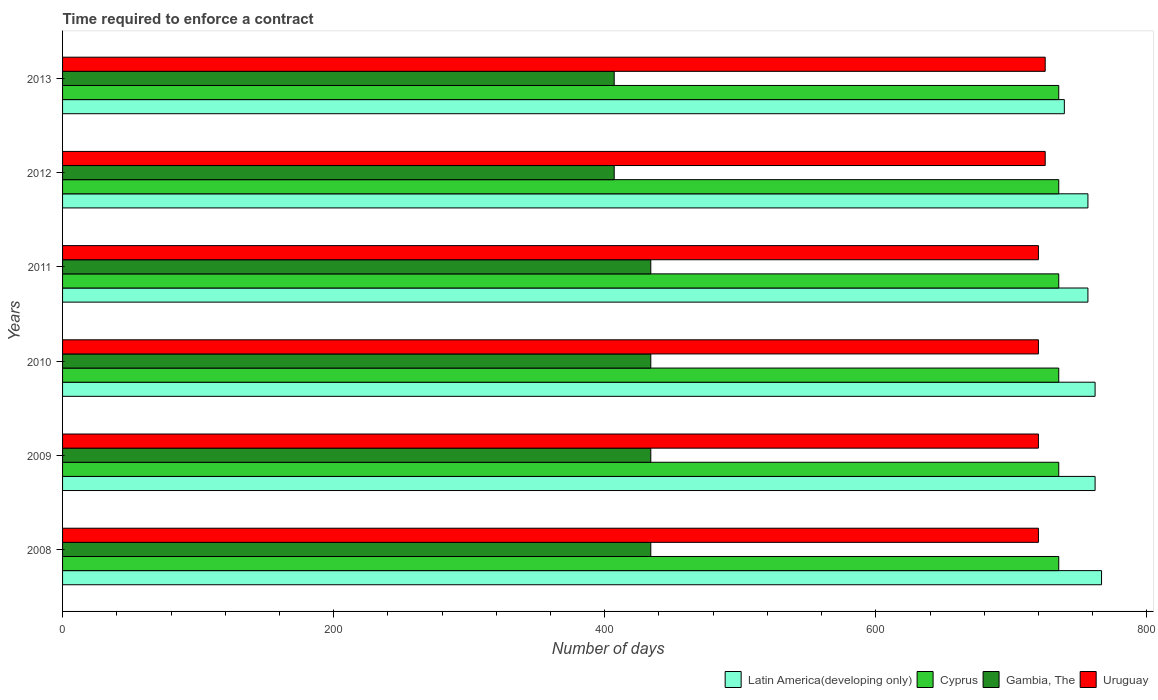Are the number of bars per tick equal to the number of legend labels?
Make the answer very short. Yes. Are the number of bars on each tick of the Y-axis equal?
Your answer should be compact. Yes. How many bars are there on the 6th tick from the top?
Offer a terse response. 4. How many bars are there on the 6th tick from the bottom?
Give a very brief answer. 4. What is the number of days required to enforce a contract in Gambia, The in 2011?
Your response must be concise. 434. Across all years, what is the maximum number of days required to enforce a contract in Latin America(developing only)?
Offer a very short reply. 766.57. Across all years, what is the minimum number of days required to enforce a contract in Uruguay?
Ensure brevity in your answer.  720. What is the total number of days required to enforce a contract in Latin America(developing only) in the graph?
Offer a terse response. 4542.37. What is the difference between the number of days required to enforce a contract in Gambia, The in 2010 and the number of days required to enforce a contract in Latin America(developing only) in 2009?
Make the answer very short. -327.81. What is the average number of days required to enforce a contract in Gambia, The per year?
Your response must be concise. 425. In the year 2011, what is the difference between the number of days required to enforce a contract in Latin America(developing only) and number of days required to enforce a contract in Uruguay?
Provide a short and direct response. 36.52. What is the ratio of the number of days required to enforce a contract in Latin America(developing only) in 2012 to that in 2013?
Make the answer very short. 1.02. What is the difference between the highest and the lowest number of days required to enforce a contract in Latin America(developing only)?
Your answer should be compact. 27.44. What does the 1st bar from the top in 2011 represents?
Offer a very short reply. Uruguay. What does the 3rd bar from the bottom in 2010 represents?
Your response must be concise. Gambia, The. Is it the case that in every year, the sum of the number of days required to enforce a contract in Uruguay and number of days required to enforce a contract in Gambia, The is greater than the number of days required to enforce a contract in Latin America(developing only)?
Ensure brevity in your answer.  Yes. How many bars are there?
Offer a terse response. 24. How many years are there in the graph?
Give a very brief answer. 6. Are the values on the major ticks of X-axis written in scientific E-notation?
Offer a terse response. No. Where does the legend appear in the graph?
Provide a short and direct response. Bottom right. How are the legend labels stacked?
Offer a terse response. Horizontal. What is the title of the graph?
Your answer should be compact. Time required to enforce a contract. Does "Greece" appear as one of the legend labels in the graph?
Your answer should be compact. No. What is the label or title of the X-axis?
Your response must be concise. Number of days. What is the label or title of the Y-axis?
Give a very brief answer. Years. What is the Number of days of Latin America(developing only) in 2008?
Your answer should be compact. 766.57. What is the Number of days of Cyprus in 2008?
Ensure brevity in your answer.  735. What is the Number of days in Gambia, The in 2008?
Offer a terse response. 434. What is the Number of days of Uruguay in 2008?
Make the answer very short. 720. What is the Number of days in Latin America(developing only) in 2009?
Make the answer very short. 761.81. What is the Number of days of Cyprus in 2009?
Provide a short and direct response. 735. What is the Number of days of Gambia, The in 2009?
Offer a terse response. 434. What is the Number of days of Uruguay in 2009?
Keep it short and to the point. 720. What is the Number of days in Latin America(developing only) in 2010?
Offer a terse response. 761.81. What is the Number of days in Cyprus in 2010?
Provide a succinct answer. 735. What is the Number of days in Gambia, The in 2010?
Offer a terse response. 434. What is the Number of days of Uruguay in 2010?
Your answer should be compact. 720. What is the Number of days of Latin America(developing only) in 2011?
Your answer should be compact. 756.52. What is the Number of days of Cyprus in 2011?
Provide a succinct answer. 735. What is the Number of days of Gambia, The in 2011?
Your answer should be very brief. 434. What is the Number of days in Uruguay in 2011?
Make the answer very short. 720. What is the Number of days of Latin America(developing only) in 2012?
Offer a terse response. 756.52. What is the Number of days of Cyprus in 2012?
Provide a succinct answer. 735. What is the Number of days of Gambia, The in 2012?
Your response must be concise. 407. What is the Number of days in Uruguay in 2012?
Ensure brevity in your answer.  725. What is the Number of days of Latin America(developing only) in 2013?
Keep it short and to the point. 739.13. What is the Number of days in Cyprus in 2013?
Your response must be concise. 735. What is the Number of days in Gambia, The in 2013?
Give a very brief answer. 407. What is the Number of days in Uruguay in 2013?
Provide a short and direct response. 725. Across all years, what is the maximum Number of days in Latin America(developing only)?
Give a very brief answer. 766.57. Across all years, what is the maximum Number of days in Cyprus?
Provide a succinct answer. 735. Across all years, what is the maximum Number of days in Gambia, The?
Your response must be concise. 434. Across all years, what is the maximum Number of days of Uruguay?
Provide a short and direct response. 725. Across all years, what is the minimum Number of days of Latin America(developing only)?
Your answer should be very brief. 739.13. Across all years, what is the minimum Number of days of Cyprus?
Your answer should be very brief. 735. Across all years, what is the minimum Number of days of Gambia, The?
Offer a very short reply. 407. Across all years, what is the minimum Number of days of Uruguay?
Provide a succinct answer. 720. What is the total Number of days in Latin America(developing only) in the graph?
Provide a succinct answer. 4542.37. What is the total Number of days of Cyprus in the graph?
Keep it short and to the point. 4410. What is the total Number of days in Gambia, The in the graph?
Your response must be concise. 2550. What is the total Number of days of Uruguay in the graph?
Your answer should be very brief. 4330. What is the difference between the Number of days in Latin America(developing only) in 2008 and that in 2009?
Ensure brevity in your answer.  4.76. What is the difference between the Number of days of Uruguay in 2008 and that in 2009?
Your answer should be very brief. 0. What is the difference between the Number of days in Latin America(developing only) in 2008 and that in 2010?
Keep it short and to the point. 4.76. What is the difference between the Number of days in Gambia, The in 2008 and that in 2010?
Your response must be concise. 0. What is the difference between the Number of days of Uruguay in 2008 and that in 2010?
Offer a terse response. 0. What is the difference between the Number of days of Latin America(developing only) in 2008 and that in 2011?
Offer a very short reply. 10.05. What is the difference between the Number of days in Gambia, The in 2008 and that in 2011?
Give a very brief answer. 0. What is the difference between the Number of days of Uruguay in 2008 and that in 2011?
Your answer should be compact. 0. What is the difference between the Number of days in Latin America(developing only) in 2008 and that in 2012?
Ensure brevity in your answer.  10.05. What is the difference between the Number of days of Uruguay in 2008 and that in 2012?
Keep it short and to the point. -5. What is the difference between the Number of days in Latin America(developing only) in 2008 and that in 2013?
Ensure brevity in your answer.  27.44. What is the difference between the Number of days of Uruguay in 2008 and that in 2013?
Your answer should be compact. -5. What is the difference between the Number of days in Latin America(developing only) in 2009 and that in 2010?
Your answer should be very brief. 0. What is the difference between the Number of days in Cyprus in 2009 and that in 2010?
Your response must be concise. 0. What is the difference between the Number of days in Gambia, The in 2009 and that in 2010?
Ensure brevity in your answer.  0. What is the difference between the Number of days in Latin America(developing only) in 2009 and that in 2011?
Your answer should be very brief. 5.29. What is the difference between the Number of days in Cyprus in 2009 and that in 2011?
Your answer should be very brief. 0. What is the difference between the Number of days in Gambia, The in 2009 and that in 2011?
Give a very brief answer. 0. What is the difference between the Number of days in Latin America(developing only) in 2009 and that in 2012?
Keep it short and to the point. 5.29. What is the difference between the Number of days of Latin America(developing only) in 2009 and that in 2013?
Give a very brief answer. 22.68. What is the difference between the Number of days of Cyprus in 2009 and that in 2013?
Keep it short and to the point. 0. What is the difference between the Number of days in Latin America(developing only) in 2010 and that in 2011?
Your answer should be compact. 5.29. What is the difference between the Number of days in Cyprus in 2010 and that in 2011?
Keep it short and to the point. 0. What is the difference between the Number of days in Gambia, The in 2010 and that in 2011?
Your response must be concise. 0. What is the difference between the Number of days of Uruguay in 2010 and that in 2011?
Make the answer very short. 0. What is the difference between the Number of days of Latin America(developing only) in 2010 and that in 2012?
Your response must be concise. 5.29. What is the difference between the Number of days of Latin America(developing only) in 2010 and that in 2013?
Give a very brief answer. 22.68. What is the difference between the Number of days in Cyprus in 2010 and that in 2013?
Make the answer very short. 0. What is the difference between the Number of days of Gambia, The in 2010 and that in 2013?
Your answer should be compact. 27. What is the difference between the Number of days of Cyprus in 2011 and that in 2012?
Ensure brevity in your answer.  0. What is the difference between the Number of days in Uruguay in 2011 and that in 2012?
Your response must be concise. -5. What is the difference between the Number of days of Latin America(developing only) in 2011 and that in 2013?
Your answer should be compact. 17.39. What is the difference between the Number of days of Gambia, The in 2011 and that in 2013?
Offer a very short reply. 27. What is the difference between the Number of days in Uruguay in 2011 and that in 2013?
Your answer should be very brief. -5. What is the difference between the Number of days of Latin America(developing only) in 2012 and that in 2013?
Offer a very short reply. 17.39. What is the difference between the Number of days of Cyprus in 2012 and that in 2013?
Provide a succinct answer. 0. What is the difference between the Number of days in Uruguay in 2012 and that in 2013?
Offer a terse response. 0. What is the difference between the Number of days of Latin America(developing only) in 2008 and the Number of days of Cyprus in 2009?
Offer a very short reply. 31.57. What is the difference between the Number of days of Latin America(developing only) in 2008 and the Number of days of Gambia, The in 2009?
Offer a very short reply. 332.57. What is the difference between the Number of days in Latin America(developing only) in 2008 and the Number of days in Uruguay in 2009?
Offer a very short reply. 46.57. What is the difference between the Number of days in Cyprus in 2008 and the Number of days in Gambia, The in 2009?
Ensure brevity in your answer.  301. What is the difference between the Number of days in Cyprus in 2008 and the Number of days in Uruguay in 2009?
Offer a very short reply. 15. What is the difference between the Number of days of Gambia, The in 2008 and the Number of days of Uruguay in 2009?
Your answer should be very brief. -286. What is the difference between the Number of days in Latin America(developing only) in 2008 and the Number of days in Cyprus in 2010?
Offer a very short reply. 31.57. What is the difference between the Number of days of Latin America(developing only) in 2008 and the Number of days of Gambia, The in 2010?
Your answer should be compact. 332.57. What is the difference between the Number of days of Latin America(developing only) in 2008 and the Number of days of Uruguay in 2010?
Make the answer very short. 46.57. What is the difference between the Number of days of Cyprus in 2008 and the Number of days of Gambia, The in 2010?
Give a very brief answer. 301. What is the difference between the Number of days in Gambia, The in 2008 and the Number of days in Uruguay in 2010?
Make the answer very short. -286. What is the difference between the Number of days in Latin America(developing only) in 2008 and the Number of days in Cyprus in 2011?
Your answer should be very brief. 31.57. What is the difference between the Number of days in Latin America(developing only) in 2008 and the Number of days in Gambia, The in 2011?
Offer a very short reply. 332.57. What is the difference between the Number of days in Latin America(developing only) in 2008 and the Number of days in Uruguay in 2011?
Offer a terse response. 46.57. What is the difference between the Number of days of Cyprus in 2008 and the Number of days of Gambia, The in 2011?
Your response must be concise. 301. What is the difference between the Number of days of Gambia, The in 2008 and the Number of days of Uruguay in 2011?
Offer a terse response. -286. What is the difference between the Number of days in Latin America(developing only) in 2008 and the Number of days in Cyprus in 2012?
Give a very brief answer. 31.57. What is the difference between the Number of days of Latin America(developing only) in 2008 and the Number of days of Gambia, The in 2012?
Provide a short and direct response. 359.57. What is the difference between the Number of days in Latin America(developing only) in 2008 and the Number of days in Uruguay in 2012?
Give a very brief answer. 41.57. What is the difference between the Number of days of Cyprus in 2008 and the Number of days of Gambia, The in 2012?
Give a very brief answer. 328. What is the difference between the Number of days of Cyprus in 2008 and the Number of days of Uruguay in 2012?
Offer a very short reply. 10. What is the difference between the Number of days in Gambia, The in 2008 and the Number of days in Uruguay in 2012?
Provide a succinct answer. -291. What is the difference between the Number of days of Latin America(developing only) in 2008 and the Number of days of Cyprus in 2013?
Ensure brevity in your answer.  31.57. What is the difference between the Number of days in Latin America(developing only) in 2008 and the Number of days in Gambia, The in 2013?
Your response must be concise. 359.57. What is the difference between the Number of days in Latin America(developing only) in 2008 and the Number of days in Uruguay in 2013?
Your response must be concise. 41.57. What is the difference between the Number of days of Cyprus in 2008 and the Number of days of Gambia, The in 2013?
Ensure brevity in your answer.  328. What is the difference between the Number of days of Gambia, The in 2008 and the Number of days of Uruguay in 2013?
Give a very brief answer. -291. What is the difference between the Number of days in Latin America(developing only) in 2009 and the Number of days in Cyprus in 2010?
Your response must be concise. 26.81. What is the difference between the Number of days of Latin America(developing only) in 2009 and the Number of days of Gambia, The in 2010?
Provide a short and direct response. 327.81. What is the difference between the Number of days in Latin America(developing only) in 2009 and the Number of days in Uruguay in 2010?
Your answer should be compact. 41.81. What is the difference between the Number of days in Cyprus in 2009 and the Number of days in Gambia, The in 2010?
Your response must be concise. 301. What is the difference between the Number of days of Cyprus in 2009 and the Number of days of Uruguay in 2010?
Your answer should be compact. 15. What is the difference between the Number of days in Gambia, The in 2009 and the Number of days in Uruguay in 2010?
Your answer should be very brief. -286. What is the difference between the Number of days in Latin America(developing only) in 2009 and the Number of days in Cyprus in 2011?
Your response must be concise. 26.81. What is the difference between the Number of days in Latin America(developing only) in 2009 and the Number of days in Gambia, The in 2011?
Give a very brief answer. 327.81. What is the difference between the Number of days in Latin America(developing only) in 2009 and the Number of days in Uruguay in 2011?
Provide a succinct answer. 41.81. What is the difference between the Number of days of Cyprus in 2009 and the Number of days of Gambia, The in 2011?
Give a very brief answer. 301. What is the difference between the Number of days of Cyprus in 2009 and the Number of days of Uruguay in 2011?
Your answer should be compact. 15. What is the difference between the Number of days in Gambia, The in 2009 and the Number of days in Uruguay in 2011?
Provide a short and direct response. -286. What is the difference between the Number of days of Latin America(developing only) in 2009 and the Number of days of Cyprus in 2012?
Make the answer very short. 26.81. What is the difference between the Number of days in Latin America(developing only) in 2009 and the Number of days in Gambia, The in 2012?
Offer a very short reply. 354.81. What is the difference between the Number of days of Latin America(developing only) in 2009 and the Number of days of Uruguay in 2012?
Your answer should be compact. 36.81. What is the difference between the Number of days in Cyprus in 2009 and the Number of days in Gambia, The in 2012?
Your answer should be compact. 328. What is the difference between the Number of days in Gambia, The in 2009 and the Number of days in Uruguay in 2012?
Your answer should be compact. -291. What is the difference between the Number of days in Latin America(developing only) in 2009 and the Number of days in Cyprus in 2013?
Provide a short and direct response. 26.81. What is the difference between the Number of days in Latin America(developing only) in 2009 and the Number of days in Gambia, The in 2013?
Your answer should be compact. 354.81. What is the difference between the Number of days in Latin America(developing only) in 2009 and the Number of days in Uruguay in 2013?
Offer a very short reply. 36.81. What is the difference between the Number of days in Cyprus in 2009 and the Number of days in Gambia, The in 2013?
Keep it short and to the point. 328. What is the difference between the Number of days in Cyprus in 2009 and the Number of days in Uruguay in 2013?
Make the answer very short. 10. What is the difference between the Number of days in Gambia, The in 2009 and the Number of days in Uruguay in 2013?
Make the answer very short. -291. What is the difference between the Number of days in Latin America(developing only) in 2010 and the Number of days in Cyprus in 2011?
Provide a succinct answer. 26.81. What is the difference between the Number of days in Latin America(developing only) in 2010 and the Number of days in Gambia, The in 2011?
Provide a succinct answer. 327.81. What is the difference between the Number of days of Latin America(developing only) in 2010 and the Number of days of Uruguay in 2011?
Make the answer very short. 41.81. What is the difference between the Number of days of Cyprus in 2010 and the Number of days of Gambia, The in 2011?
Offer a terse response. 301. What is the difference between the Number of days in Gambia, The in 2010 and the Number of days in Uruguay in 2011?
Your answer should be very brief. -286. What is the difference between the Number of days in Latin America(developing only) in 2010 and the Number of days in Cyprus in 2012?
Provide a succinct answer. 26.81. What is the difference between the Number of days in Latin America(developing only) in 2010 and the Number of days in Gambia, The in 2012?
Ensure brevity in your answer.  354.81. What is the difference between the Number of days of Latin America(developing only) in 2010 and the Number of days of Uruguay in 2012?
Ensure brevity in your answer.  36.81. What is the difference between the Number of days in Cyprus in 2010 and the Number of days in Gambia, The in 2012?
Your answer should be very brief. 328. What is the difference between the Number of days of Gambia, The in 2010 and the Number of days of Uruguay in 2012?
Offer a terse response. -291. What is the difference between the Number of days of Latin America(developing only) in 2010 and the Number of days of Cyprus in 2013?
Provide a succinct answer. 26.81. What is the difference between the Number of days of Latin America(developing only) in 2010 and the Number of days of Gambia, The in 2013?
Your answer should be compact. 354.81. What is the difference between the Number of days of Latin America(developing only) in 2010 and the Number of days of Uruguay in 2013?
Give a very brief answer. 36.81. What is the difference between the Number of days in Cyprus in 2010 and the Number of days in Gambia, The in 2013?
Provide a short and direct response. 328. What is the difference between the Number of days in Gambia, The in 2010 and the Number of days in Uruguay in 2013?
Offer a terse response. -291. What is the difference between the Number of days of Latin America(developing only) in 2011 and the Number of days of Cyprus in 2012?
Your answer should be very brief. 21.52. What is the difference between the Number of days of Latin America(developing only) in 2011 and the Number of days of Gambia, The in 2012?
Ensure brevity in your answer.  349.52. What is the difference between the Number of days in Latin America(developing only) in 2011 and the Number of days in Uruguay in 2012?
Ensure brevity in your answer.  31.52. What is the difference between the Number of days of Cyprus in 2011 and the Number of days of Gambia, The in 2012?
Give a very brief answer. 328. What is the difference between the Number of days of Gambia, The in 2011 and the Number of days of Uruguay in 2012?
Offer a very short reply. -291. What is the difference between the Number of days of Latin America(developing only) in 2011 and the Number of days of Cyprus in 2013?
Ensure brevity in your answer.  21.52. What is the difference between the Number of days of Latin America(developing only) in 2011 and the Number of days of Gambia, The in 2013?
Your response must be concise. 349.52. What is the difference between the Number of days of Latin America(developing only) in 2011 and the Number of days of Uruguay in 2013?
Provide a short and direct response. 31.52. What is the difference between the Number of days in Cyprus in 2011 and the Number of days in Gambia, The in 2013?
Give a very brief answer. 328. What is the difference between the Number of days of Gambia, The in 2011 and the Number of days of Uruguay in 2013?
Give a very brief answer. -291. What is the difference between the Number of days in Latin America(developing only) in 2012 and the Number of days in Cyprus in 2013?
Provide a short and direct response. 21.52. What is the difference between the Number of days in Latin America(developing only) in 2012 and the Number of days in Gambia, The in 2013?
Provide a short and direct response. 349.52. What is the difference between the Number of days in Latin America(developing only) in 2012 and the Number of days in Uruguay in 2013?
Offer a terse response. 31.52. What is the difference between the Number of days of Cyprus in 2012 and the Number of days of Gambia, The in 2013?
Make the answer very short. 328. What is the difference between the Number of days in Cyprus in 2012 and the Number of days in Uruguay in 2013?
Your response must be concise. 10. What is the difference between the Number of days in Gambia, The in 2012 and the Number of days in Uruguay in 2013?
Your answer should be compact. -318. What is the average Number of days in Latin America(developing only) per year?
Offer a very short reply. 757.06. What is the average Number of days of Cyprus per year?
Ensure brevity in your answer.  735. What is the average Number of days in Gambia, The per year?
Make the answer very short. 425. What is the average Number of days of Uruguay per year?
Give a very brief answer. 721.67. In the year 2008, what is the difference between the Number of days of Latin America(developing only) and Number of days of Cyprus?
Your answer should be compact. 31.57. In the year 2008, what is the difference between the Number of days in Latin America(developing only) and Number of days in Gambia, The?
Provide a succinct answer. 332.57. In the year 2008, what is the difference between the Number of days of Latin America(developing only) and Number of days of Uruguay?
Your answer should be compact. 46.57. In the year 2008, what is the difference between the Number of days of Cyprus and Number of days of Gambia, The?
Ensure brevity in your answer.  301. In the year 2008, what is the difference between the Number of days in Cyprus and Number of days in Uruguay?
Provide a short and direct response. 15. In the year 2008, what is the difference between the Number of days of Gambia, The and Number of days of Uruguay?
Your answer should be very brief. -286. In the year 2009, what is the difference between the Number of days in Latin America(developing only) and Number of days in Cyprus?
Ensure brevity in your answer.  26.81. In the year 2009, what is the difference between the Number of days of Latin America(developing only) and Number of days of Gambia, The?
Provide a succinct answer. 327.81. In the year 2009, what is the difference between the Number of days of Latin America(developing only) and Number of days of Uruguay?
Your answer should be very brief. 41.81. In the year 2009, what is the difference between the Number of days in Cyprus and Number of days in Gambia, The?
Provide a short and direct response. 301. In the year 2009, what is the difference between the Number of days in Cyprus and Number of days in Uruguay?
Your response must be concise. 15. In the year 2009, what is the difference between the Number of days of Gambia, The and Number of days of Uruguay?
Make the answer very short. -286. In the year 2010, what is the difference between the Number of days of Latin America(developing only) and Number of days of Cyprus?
Keep it short and to the point. 26.81. In the year 2010, what is the difference between the Number of days of Latin America(developing only) and Number of days of Gambia, The?
Keep it short and to the point. 327.81. In the year 2010, what is the difference between the Number of days of Latin America(developing only) and Number of days of Uruguay?
Offer a very short reply. 41.81. In the year 2010, what is the difference between the Number of days in Cyprus and Number of days in Gambia, The?
Provide a short and direct response. 301. In the year 2010, what is the difference between the Number of days in Cyprus and Number of days in Uruguay?
Your answer should be very brief. 15. In the year 2010, what is the difference between the Number of days in Gambia, The and Number of days in Uruguay?
Offer a very short reply. -286. In the year 2011, what is the difference between the Number of days in Latin America(developing only) and Number of days in Cyprus?
Offer a very short reply. 21.52. In the year 2011, what is the difference between the Number of days of Latin America(developing only) and Number of days of Gambia, The?
Ensure brevity in your answer.  322.52. In the year 2011, what is the difference between the Number of days of Latin America(developing only) and Number of days of Uruguay?
Your response must be concise. 36.52. In the year 2011, what is the difference between the Number of days in Cyprus and Number of days in Gambia, The?
Provide a succinct answer. 301. In the year 2011, what is the difference between the Number of days of Cyprus and Number of days of Uruguay?
Provide a short and direct response. 15. In the year 2011, what is the difference between the Number of days in Gambia, The and Number of days in Uruguay?
Your response must be concise. -286. In the year 2012, what is the difference between the Number of days in Latin America(developing only) and Number of days in Cyprus?
Your answer should be compact. 21.52. In the year 2012, what is the difference between the Number of days of Latin America(developing only) and Number of days of Gambia, The?
Your answer should be compact. 349.52. In the year 2012, what is the difference between the Number of days of Latin America(developing only) and Number of days of Uruguay?
Your answer should be very brief. 31.52. In the year 2012, what is the difference between the Number of days of Cyprus and Number of days of Gambia, The?
Your answer should be very brief. 328. In the year 2012, what is the difference between the Number of days in Cyprus and Number of days in Uruguay?
Ensure brevity in your answer.  10. In the year 2012, what is the difference between the Number of days of Gambia, The and Number of days of Uruguay?
Provide a short and direct response. -318. In the year 2013, what is the difference between the Number of days in Latin America(developing only) and Number of days in Cyprus?
Your response must be concise. 4.13. In the year 2013, what is the difference between the Number of days of Latin America(developing only) and Number of days of Gambia, The?
Provide a succinct answer. 332.13. In the year 2013, what is the difference between the Number of days of Latin America(developing only) and Number of days of Uruguay?
Offer a very short reply. 14.13. In the year 2013, what is the difference between the Number of days in Cyprus and Number of days in Gambia, The?
Give a very brief answer. 328. In the year 2013, what is the difference between the Number of days in Cyprus and Number of days in Uruguay?
Provide a succinct answer. 10. In the year 2013, what is the difference between the Number of days of Gambia, The and Number of days of Uruguay?
Ensure brevity in your answer.  -318. What is the ratio of the Number of days of Latin America(developing only) in 2008 to that in 2009?
Your response must be concise. 1.01. What is the ratio of the Number of days of Gambia, The in 2008 to that in 2009?
Provide a succinct answer. 1. What is the ratio of the Number of days in Uruguay in 2008 to that in 2009?
Your response must be concise. 1. What is the ratio of the Number of days in Latin America(developing only) in 2008 to that in 2010?
Make the answer very short. 1.01. What is the ratio of the Number of days in Gambia, The in 2008 to that in 2010?
Keep it short and to the point. 1. What is the ratio of the Number of days in Latin America(developing only) in 2008 to that in 2011?
Ensure brevity in your answer.  1.01. What is the ratio of the Number of days of Uruguay in 2008 to that in 2011?
Provide a succinct answer. 1. What is the ratio of the Number of days in Latin America(developing only) in 2008 to that in 2012?
Your response must be concise. 1.01. What is the ratio of the Number of days of Cyprus in 2008 to that in 2012?
Your answer should be compact. 1. What is the ratio of the Number of days in Gambia, The in 2008 to that in 2012?
Make the answer very short. 1.07. What is the ratio of the Number of days of Latin America(developing only) in 2008 to that in 2013?
Offer a very short reply. 1.04. What is the ratio of the Number of days of Gambia, The in 2008 to that in 2013?
Provide a succinct answer. 1.07. What is the ratio of the Number of days of Cyprus in 2009 to that in 2010?
Your answer should be compact. 1. What is the ratio of the Number of days in Latin America(developing only) in 2009 to that in 2011?
Offer a very short reply. 1.01. What is the ratio of the Number of days in Cyprus in 2009 to that in 2011?
Your answer should be compact. 1. What is the ratio of the Number of days in Gambia, The in 2009 to that in 2011?
Offer a very short reply. 1. What is the ratio of the Number of days in Latin America(developing only) in 2009 to that in 2012?
Your response must be concise. 1.01. What is the ratio of the Number of days of Gambia, The in 2009 to that in 2012?
Ensure brevity in your answer.  1.07. What is the ratio of the Number of days of Latin America(developing only) in 2009 to that in 2013?
Offer a very short reply. 1.03. What is the ratio of the Number of days of Gambia, The in 2009 to that in 2013?
Your answer should be compact. 1.07. What is the ratio of the Number of days of Uruguay in 2009 to that in 2013?
Provide a short and direct response. 0.99. What is the ratio of the Number of days in Latin America(developing only) in 2010 to that in 2011?
Provide a short and direct response. 1.01. What is the ratio of the Number of days in Cyprus in 2010 to that in 2011?
Give a very brief answer. 1. What is the ratio of the Number of days in Uruguay in 2010 to that in 2011?
Offer a very short reply. 1. What is the ratio of the Number of days in Latin America(developing only) in 2010 to that in 2012?
Offer a very short reply. 1.01. What is the ratio of the Number of days in Cyprus in 2010 to that in 2012?
Make the answer very short. 1. What is the ratio of the Number of days of Gambia, The in 2010 to that in 2012?
Give a very brief answer. 1.07. What is the ratio of the Number of days of Latin America(developing only) in 2010 to that in 2013?
Keep it short and to the point. 1.03. What is the ratio of the Number of days in Cyprus in 2010 to that in 2013?
Make the answer very short. 1. What is the ratio of the Number of days of Gambia, The in 2010 to that in 2013?
Provide a short and direct response. 1.07. What is the ratio of the Number of days of Gambia, The in 2011 to that in 2012?
Give a very brief answer. 1.07. What is the ratio of the Number of days of Latin America(developing only) in 2011 to that in 2013?
Offer a terse response. 1.02. What is the ratio of the Number of days in Cyprus in 2011 to that in 2013?
Your answer should be compact. 1. What is the ratio of the Number of days of Gambia, The in 2011 to that in 2013?
Provide a succinct answer. 1.07. What is the ratio of the Number of days in Uruguay in 2011 to that in 2013?
Ensure brevity in your answer.  0.99. What is the ratio of the Number of days of Latin America(developing only) in 2012 to that in 2013?
Make the answer very short. 1.02. What is the ratio of the Number of days in Gambia, The in 2012 to that in 2013?
Make the answer very short. 1. What is the difference between the highest and the second highest Number of days of Latin America(developing only)?
Your answer should be very brief. 4.76. What is the difference between the highest and the lowest Number of days of Latin America(developing only)?
Ensure brevity in your answer.  27.44. What is the difference between the highest and the lowest Number of days in Cyprus?
Provide a succinct answer. 0. 